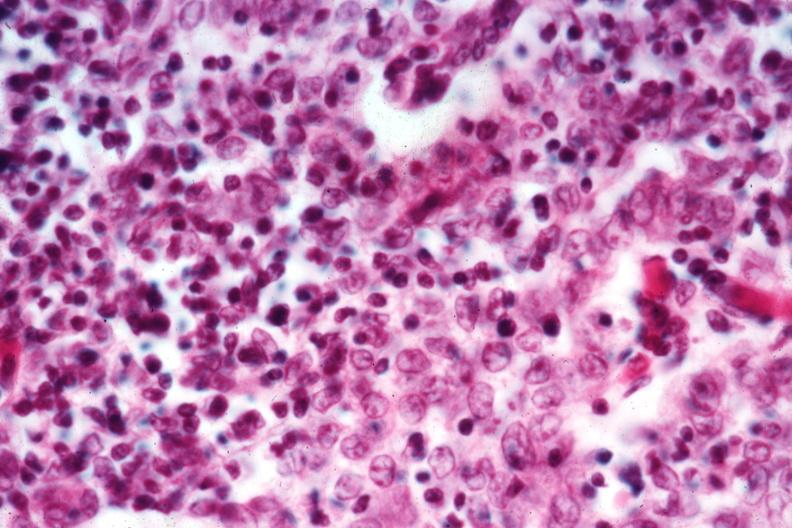s hematologic present?
Answer the question using a single word or phrase. Yes 